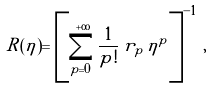<formula> <loc_0><loc_0><loc_500><loc_500>R ( \eta ) = \left [ \sum _ { p = 0 } ^ { + \infty } \frac { 1 } { p ! } \, r _ { p } \, \eta ^ { p } \right ] ^ { - 1 } \, ,</formula> 